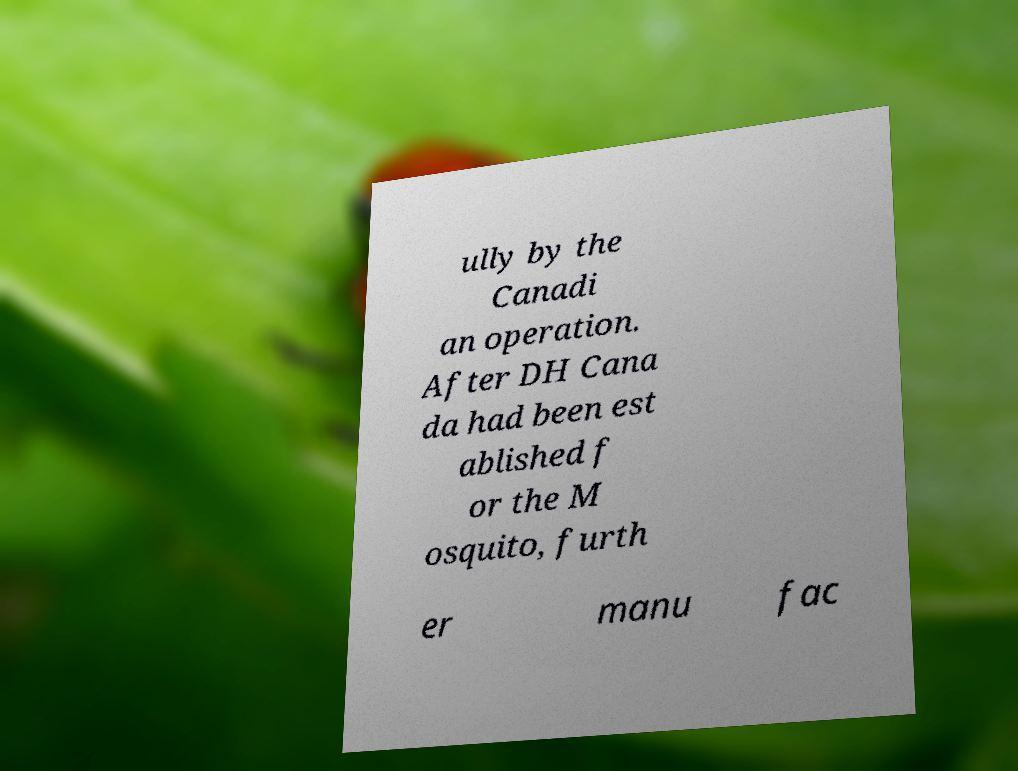For documentation purposes, I need the text within this image transcribed. Could you provide that? ully by the Canadi an operation. After DH Cana da had been est ablished f or the M osquito, furth er manu fac 